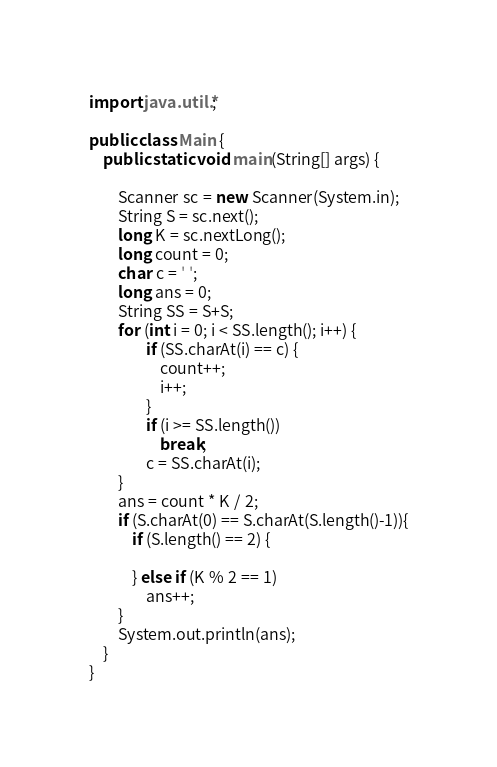<code> <loc_0><loc_0><loc_500><loc_500><_Java_>import java.util.*;
 
public class Main {
	public static void main(String[] args) {
 
		Scanner sc = new Scanner(System.in);
		String S = sc.next();
		long K = sc.nextLong();
		long count = 0;
		char c = ' ';
		long ans = 0;
		String SS = S+S;
		for (int i = 0; i < SS.length(); i++) {
				if (SS.charAt(i) == c) {
					count++;
					i++;
				}
				if (i >= SS.length())
					break;
				c = SS.charAt(i);
		}
		ans = count * K / 2;
		if (S.charAt(0) == S.charAt(S.length()-1)){
			if (S.length() == 2) {

			} else if (K % 2 == 1)
				ans++;
		}
		System.out.println(ans);
	}
}
</code> 